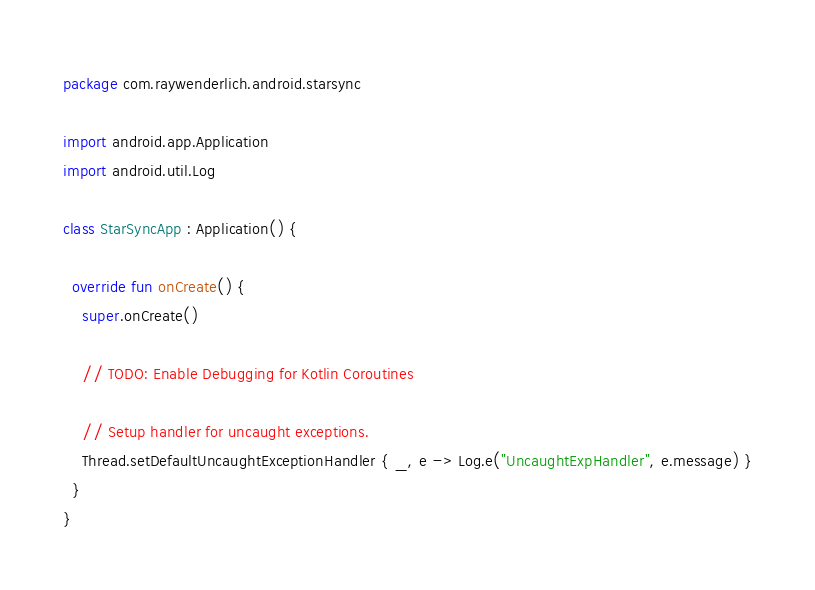<code> <loc_0><loc_0><loc_500><loc_500><_Kotlin_>package com.raywenderlich.android.starsync

import android.app.Application
import android.util.Log

class StarSyncApp : Application() {

  override fun onCreate() {
    super.onCreate()

    // TODO: Enable Debugging for Kotlin Coroutines

    // Setup handler for uncaught exceptions.
    Thread.setDefaultUncaughtExceptionHandler { _, e -> Log.e("UncaughtExpHandler", e.message) }
  }
}
</code> 